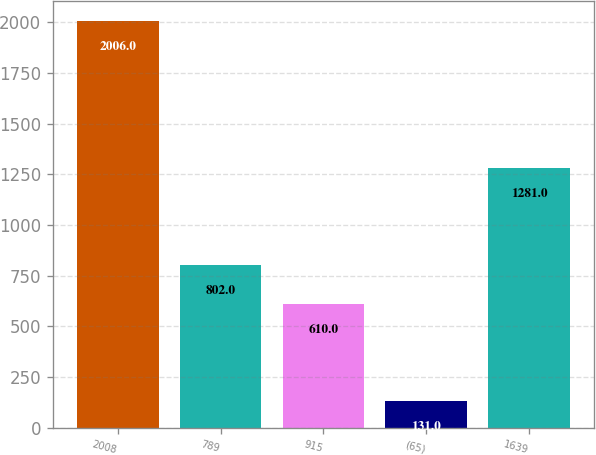<chart> <loc_0><loc_0><loc_500><loc_500><bar_chart><fcel>2008<fcel>789<fcel>915<fcel>(65)<fcel>1639<nl><fcel>2006<fcel>802<fcel>610<fcel>131<fcel>1281<nl></chart> 